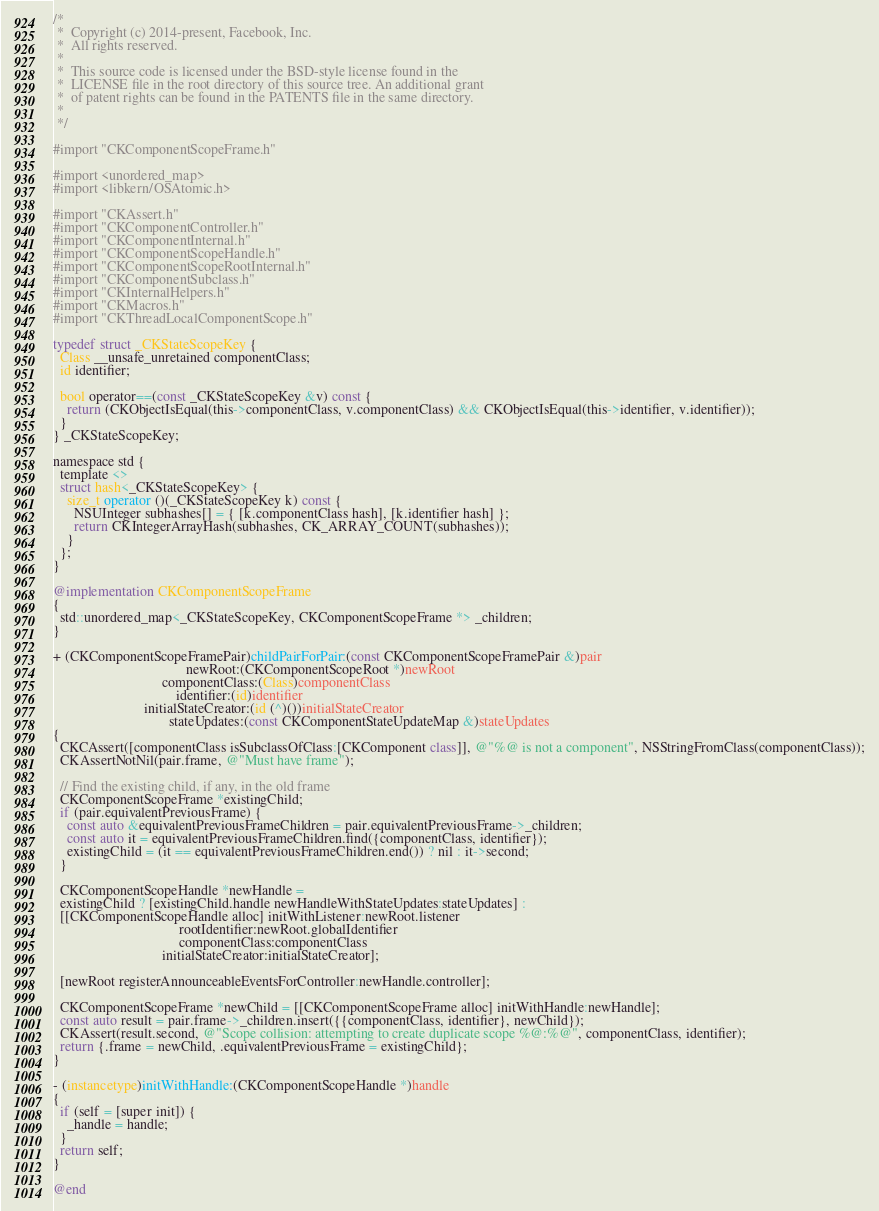Convert code to text. <code><loc_0><loc_0><loc_500><loc_500><_ObjectiveC_>/*
 *  Copyright (c) 2014-present, Facebook, Inc.
 *  All rights reserved.
 *
 *  This source code is licensed under the BSD-style license found in the
 *  LICENSE file in the root directory of this source tree. An additional grant
 *  of patent rights can be found in the PATENTS file in the same directory.
 *
 */

#import "CKComponentScopeFrame.h"

#import <unordered_map>
#import <libkern/OSAtomic.h>

#import "CKAssert.h"
#import "CKComponentController.h"
#import "CKComponentInternal.h"
#import "CKComponentScopeHandle.h"
#import "CKComponentScopeRootInternal.h"
#import "CKComponentSubclass.h"
#import "CKInternalHelpers.h"
#import "CKMacros.h"
#import "CKThreadLocalComponentScope.h"

typedef struct _CKStateScopeKey {
  Class __unsafe_unretained componentClass;
  id identifier;

  bool operator==(const _CKStateScopeKey &v) const {
    return (CKObjectIsEqual(this->componentClass, v.componentClass) && CKObjectIsEqual(this->identifier, v.identifier));
  }
} _CKStateScopeKey;

namespace std {
  template <>
  struct hash<_CKStateScopeKey> {
    size_t operator ()(_CKStateScopeKey k) const {
      NSUInteger subhashes[] = { [k.componentClass hash], [k.identifier hash] };
      return CKIntegerArrayHash(subhashes, CK_ARRAY_COUNT(subhashes));
    }
  };
}

@implementation CKComponentScopeFrame
{
  std::unordered_map<_CKStateScopeKey, CKComponentScopeFrame *> _children;
}

+ (CKComponentScopeFramePair)childPairForPair:(const CKComponentScopeFramePair &)pair
                                      newRoot:(CKComponentScopeRoot *)newRoot
                               componentClass:(Class)componentClass
                                   identifier:(id)identifier
                          initialStateCreator:(id (^)())initialStateCreator
                                 stateUpdates:(const CKComponentStateUpdateMap &)stateUpdates
{
  CKCAssert([componentClass isSubclassOfClass:[CKComponent class]], @"%@ is not a component", NSStringFromClass(componentClass));
  CKAssertNotNil(pair.frame, @"Must have frame");

  // Find the existing child, if any, in the old frame
  CKComponentScopeFrame *existingChild;
  if (pair.equivalentPreviousFrame) {
    const auto &equivalentPreviousFrameChildren = pair.equivalentPreviousFrame->_children;
    const auto it = equivalentPreviousFrameChildren.find({componentClass, identifier});
    existingChild = (it == equivalentPreviousFrameChildren.end()) ? nil : it->second;
  }

  CKComponentScopeHandle *newHandle =
  existingChild ? [existingChild.handle newHandleWithStateUpdates:stateUpdates] :
  [[CKComponentScopeHandle alloc] initWithListener:newRoot.listener
                                    rootIdentifier:newRoot.globalIdentifier
                                    componentClass:componentClass
                               initialStateCreator:initialStateCreator];

  [newRoot registerAnnounceableEventsForController:newHandle.controller];

  CKComponentScopeFrame *newChild = [[CKComponentScopeFrame alloc] initWithHandle:newHandle];
  const auto result = pair.frame->_children.insert({{componentClass, identifier}, newChild});
  CKAssert(result.second, @"Scope collision: attempting to create duplicate scope %@:%@", componentClass, identifier);
  return {.frame = newChild, .equivalentPreviousFrame = existingChild};
}

- (instancetype)initWithHandle:(CKComponentScopeHandle *)handle
{
  if (self = [super init]) {
    _handle = handle;
  }
  return self;
}

@end
</code> 